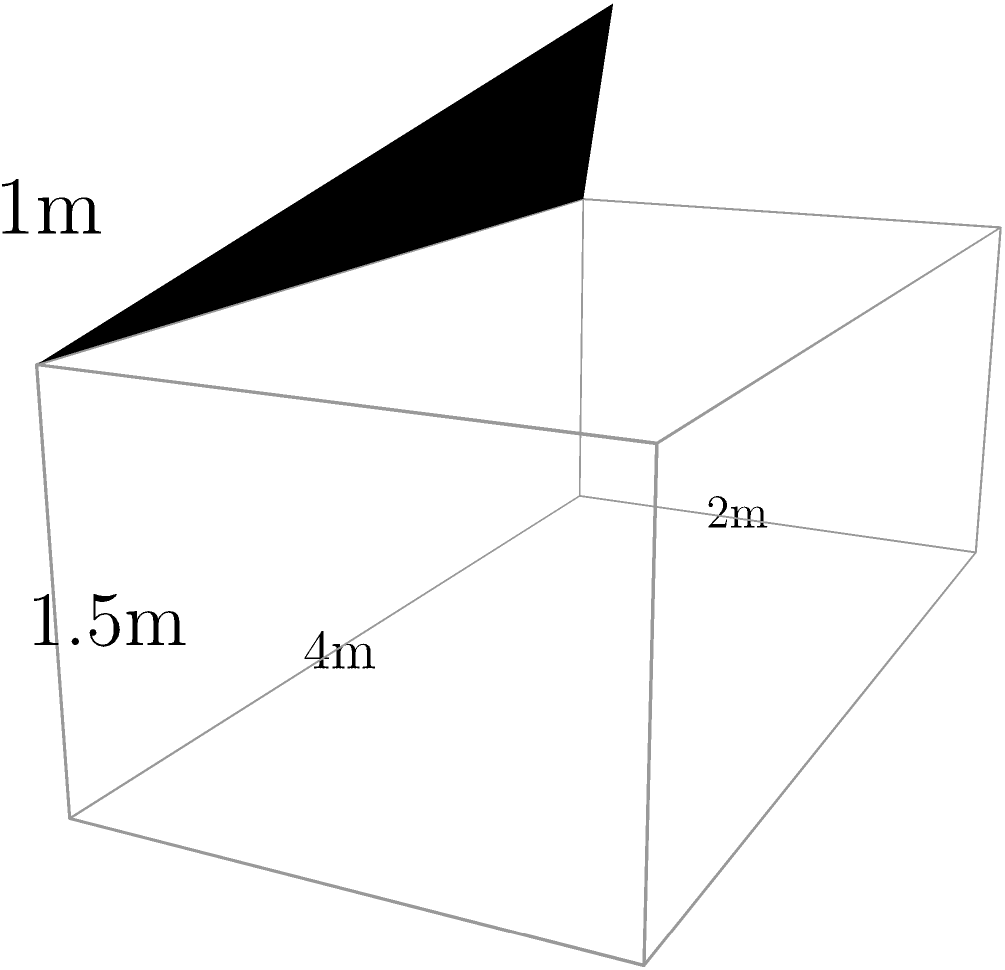Thomas the Tank Engine is helping to transport coal in a rectangular car. The coal car measures 4m long, 2m wide, and 1.5m high. The coal is piled up in the middle, forming a triangular prism shape that adds an extra 1m to the height at the center. What is the total surface area of the coal and exposed sides of the car in square meters? Let's break this down step-by-step:

1) First, let's calculate the surface area of the rectangular car:
   - Bottom: $4m \times 2m = 8m^2$
   - Two long sides: $2 \times (4m \times 1.5m) = 12m^2$
   - Two short sides: $2 \times (2m \times 1.5m) = 6m^2$
   - Total for rectangular part: $8 + 12 + 6 = 26m^2$

2) Now, let's calculate the surface area of the coal pile:
   - The coal forms a triangular prism on top of the car
   - The base of this prism is 4m x 2m
   - The height of the triangle is 1m
   - We need to calculate the slant height using the Pythagorean theorem:
     $\text{slant height} = \sqrt{2^2 + 1^2} = \sqrt{5} \approx 2.236m$

3) Surface area of the coal:
   - Two triangular ends: $2 \times (1/2 \times 2m \times 1m) = 2m^2$
   - Two slanted rectangular sides: $2 \times (4m \times 2.236m) = 17.888m^2$

4) Total surface area:
   - Rectangular car: $26m^2$
   - Coal pile: $2m^2 + 17.888m^2 = 19.888m^2$
   - Total: $26m^2 + 19.888m^2 = 45.888m^2$

Therefore, the total surface area is approximately 45.89 square meters.
Answer: 45.89 $m^2$ 